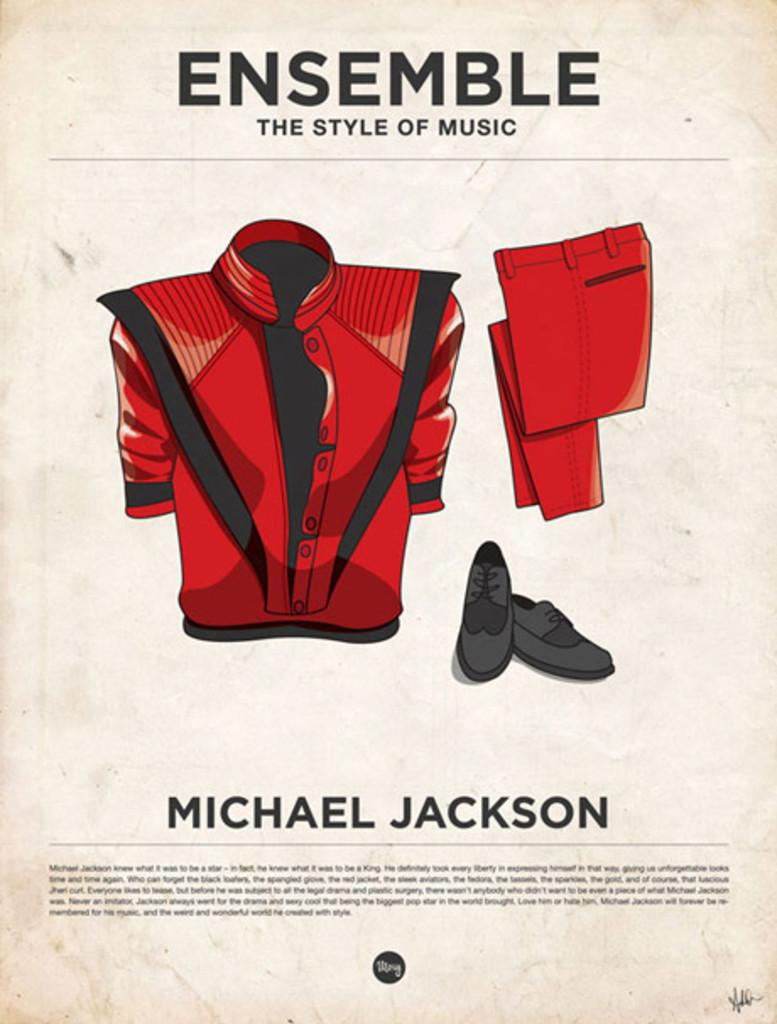Provide a one-sentence caption for the provided image. A poster shows the red outfit made famous by Michael Jackson. 